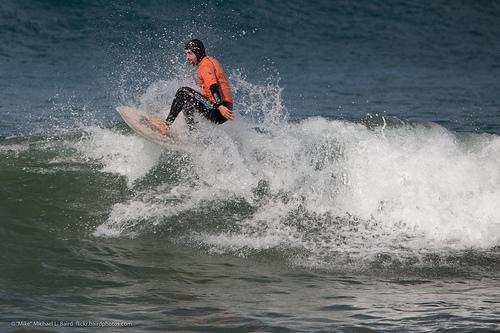Count the number of white and gray waves depicted in the image. There are a total of 10 white and gray waves in the image. Analyze the interaction between the person and the environment in the image. The surfer is dynamically interacting with the ocean waves, using his skill and balance to ride the waves on his white surfboard. Explain a possible complex reasoning behind the person's choice of clothing in the image. The man is wearing a black wet suit and a tight black hood to preserve body heat in cold ocean water, while the orange shirt provides visibility and a touch of personal style. Describe the features and action of the person on the surfboard. The man is wearing a black wet suit, orange shirt, and a tight black hood while surfing on a white surfboard amidst ocean waves. Provide a brief overview of the image's content. The image features a man surfing on a white surfboard amidst white, blue, and gray ocean waves, wearing a black wet suit, orange shirt, and a tight black hood. What emotions can be associated with the image? The image evokes excitement, freedom, and adventure associated with surfing. What colors are the waves in the image? The waves are white, blue, and gray in the image. Identify the primary activity of the man in the image. The man is surfing on a white surfboard in the ocean waves. Determine the general quality of the image based on the elements and details present. The image is of high quality, as it captures multiple elements such as the surfer, the surfboard, and the ocean waves in vivid detail. What kind of clothing is the person wearing in the image while performing the activity? The man is wearing a black wet suit, orange shirt, and a tight black hood. Which color best describes the man's hood? black Are there any dolphins jumping in the background of the image? No, it's not mentioned in the image. What does the text at the bottom of the image say? photograph is copyrighted Is there a person surfing on a pink surfboard? The image mentions a white surfboard, not a pink one. Is the man in the wet suit wearing a black hat?  yes What activity is happening in the image? surfing Which color best describes the waves in the image? white and blue Please describe the main object in the scene. a man surfing on white and blue waves Does the man have a red hat on while surfing? The image mentions the man is wearing a black hat, not a red one. Is the man wearing a pair of sneakers while surfing? The image mentions the man being barefoot on the surfboard, not wearing sneakers. Are the waves green and yellow in the ocean? The image mentions white and blue or white and gray waves, not green and yellow ones. Choose the correct statement about the man's attire:  b) man is wearing an orange shirt Please create a description of the image integrating both visual and textual elements. A man in an orange shirt and black wet suit is surfing on white and blue waves with a white surfboard, while the photograph is copyrighted. What is the color of the surfboard? white Which multi-choice option is correct? b) man is wearing a black hat Is there any indication on ownership of the photograph? Yes, it says "photograph is copyrighted" What is the main object doing in the image? riding a surfboard on white and blue waves What best describes the texture of water on the surface? white splashed water Does the man have his feet on top of the surfboard? yes, he is barefoot on top of the surfboard Identify the primary event happening in the image. man surfing a wave What is the emotion/s displayed by the man in the image? Cannot determine emotions due to lack of facial details Is the man surfing while wearing a purple wet suit? The image mentions the man is wearing a black wet suit, not a purple one. What is the predominant color of the water in the background? gray blue What type of water body is present in the image? ocean 